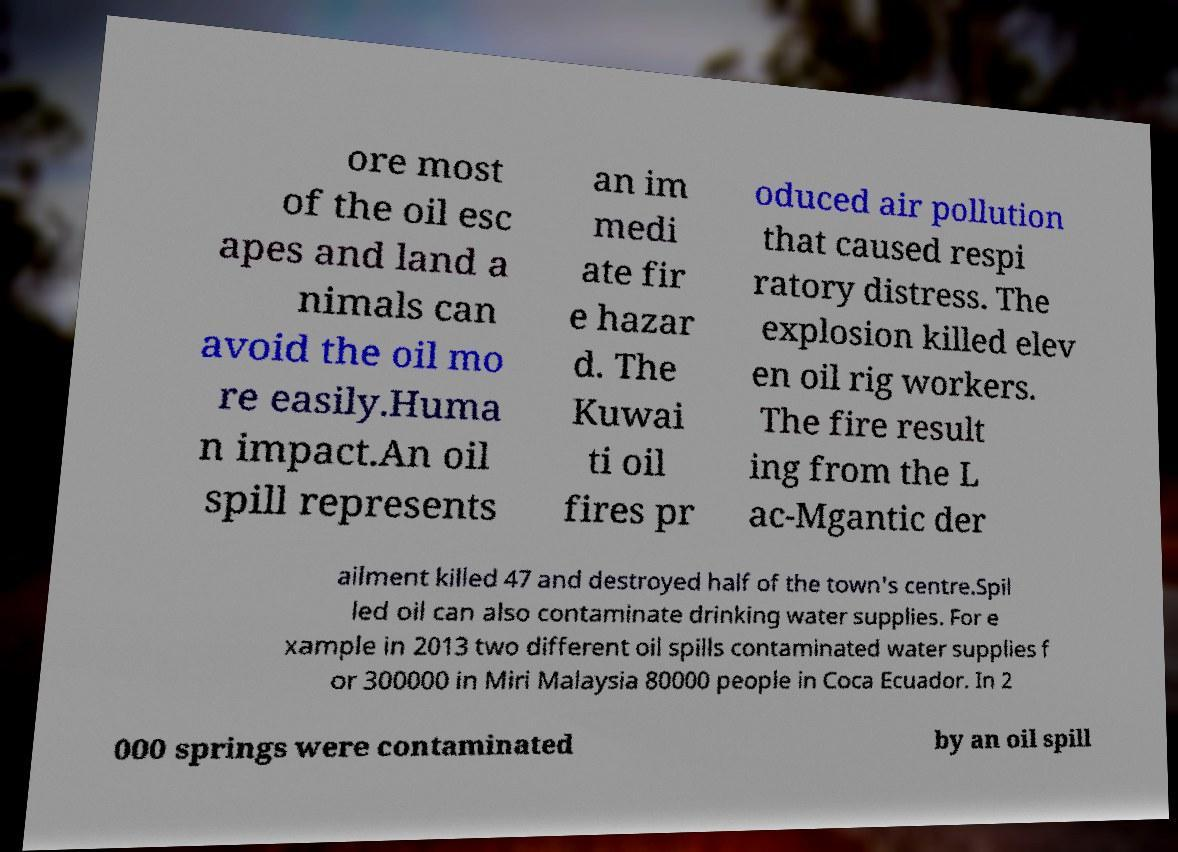Can you accurately transcribe the text from the provided image for me? ore most of the oil esc apes and land a nimals can avoid the oil mo re easily.Huma n impact.An oil spill represents an im medi ate fir e hazar d. The Kuwai ti oil fires pr oduced air pollution that caused respi ratory distress. The explosion killed elev en oil rig workers. The fire result ing from the L ac-Mgantic der ailment killed 47 and destroyed half of the town's centre.Spil led oil can also contaminate drinking water supplies. For e xample in 2013 two different oil spills contaminated water supplies f or 300000 in Miri Malaysia 80000 people in Coca Ecuador. In 2 000 springs were contaminated by an oil spill 